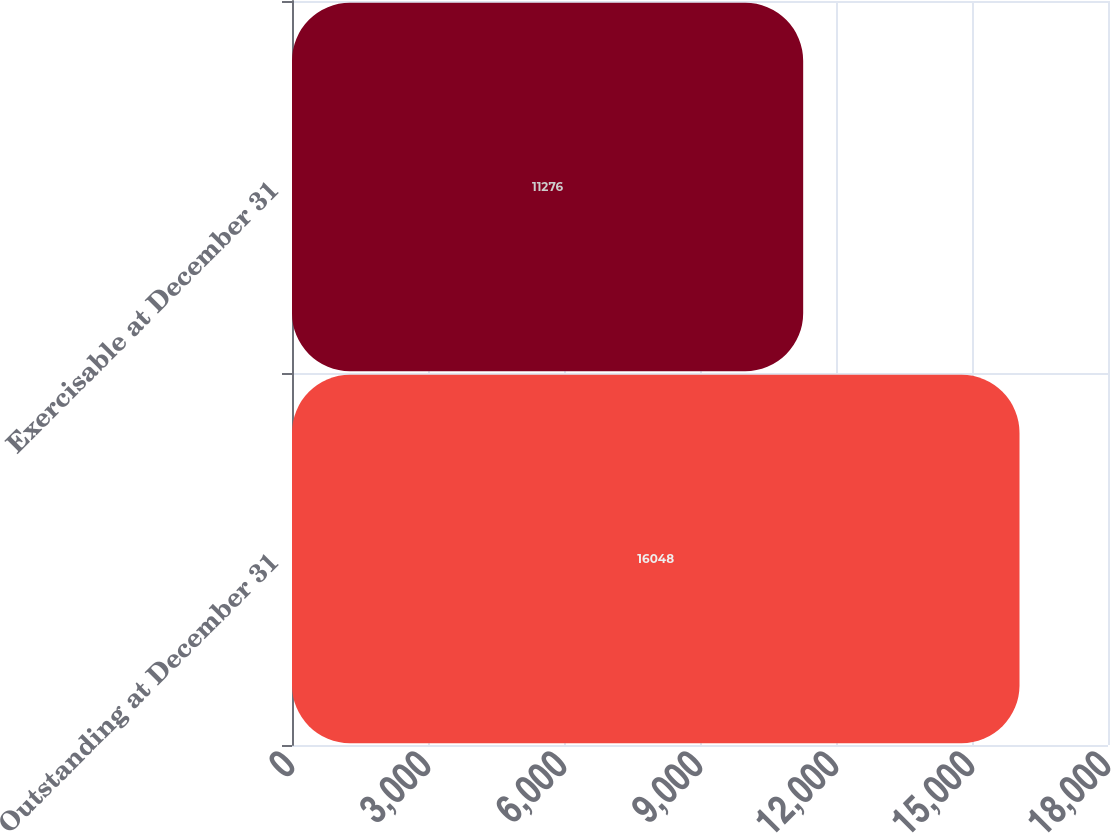Convert chart to OTSL. <chart><loc_0><loc_0><loc_500><loc_500><bar_chart><fcel>Outstanding at December 31<fcel>Exercisable at December 31<nl><fcel>16048<fcel>11276<nl></chart> 